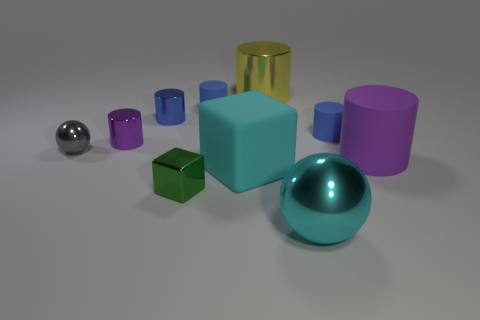How big is the shiny cube?
Offer a very short reply. Small. There is a blue thing that is made of the same material as the small ball; what shape is it?
Offer a very short reply. Cylinder. Is the number of cyan objects to the right of the big metallic ball less than the number of gray spheres?
Give a very brief answer. Yes. There is a block that is on the right side of the tiny green object; what color is it?
Keep it short and to the point. Cyan. There is a small object that is the same color as the large matte cylinder; what is its material?
Your answer should be compact. Metal. Is there another green shiny thing that has the same shape as the small green thing?
Keep it short and to the point. No. How many other yellow metal things have the same shape as the yellow object?
Give a very brief answer. 0. Is the color of the large block the same as the large metal ball?
Offer a terse response. Yes. Is the number of large rubber blocks less than the number of blue objects?
Your answer should be very brief. Yes. What is the material of the big cylinder that is in front of the gray sphere?
Give a very brief answer. Rubber. 